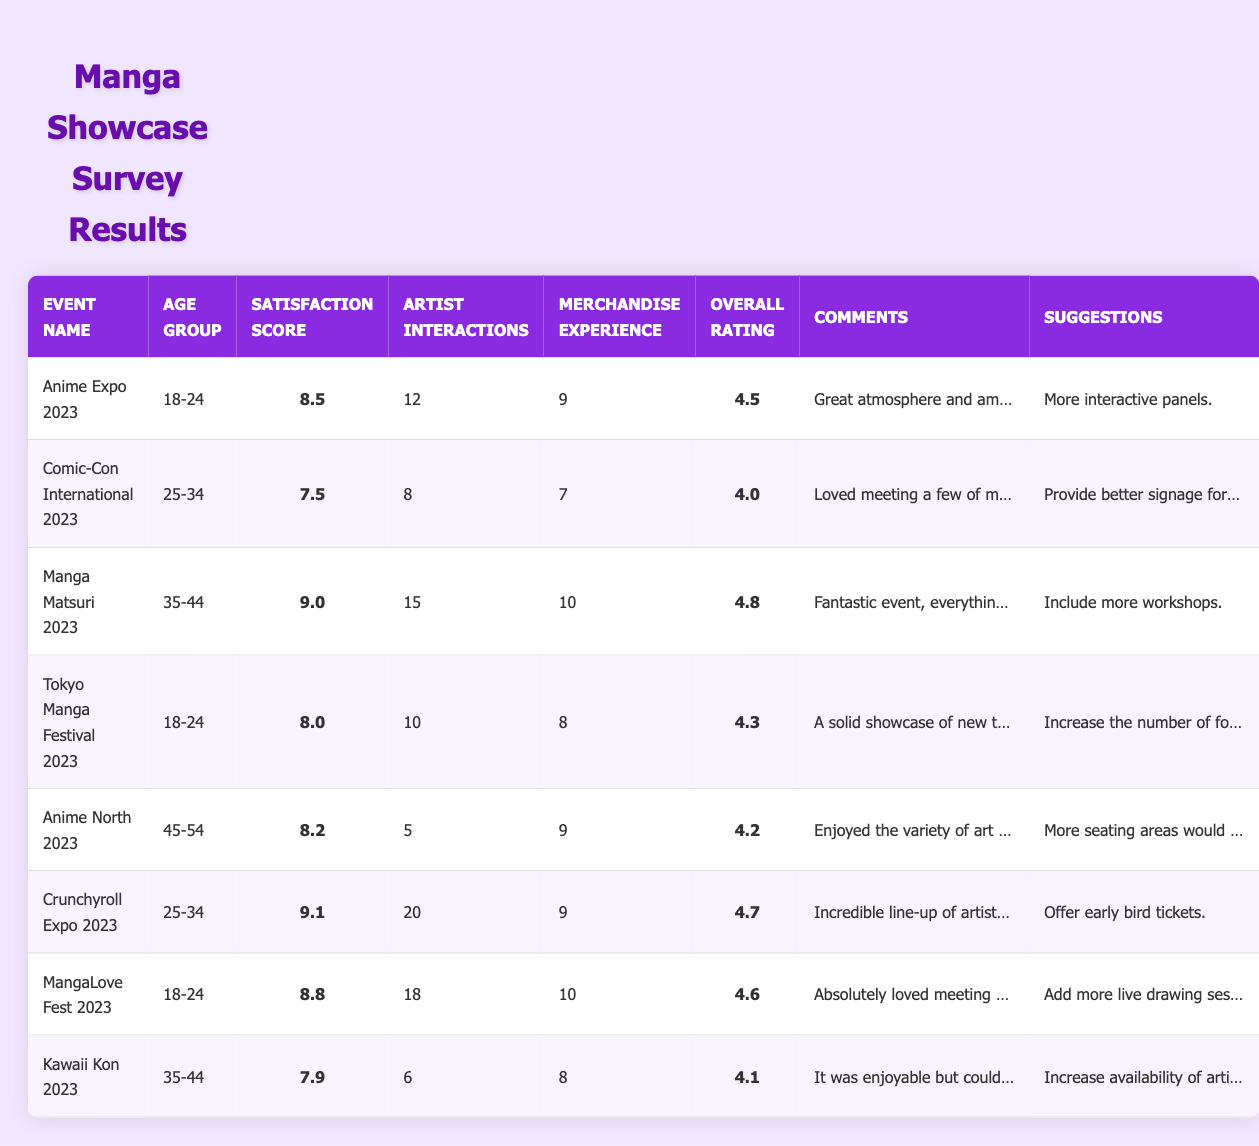What is the satisfaction score for Manga Matsuri 2023? Looking at the table, the satisfaction score for Manga Matsuri 2023 is listed as 9.0.
Answer: 9.0 Which event received the highest overall rating? The overall ratings are compared across the table, and Manga Matsuri 2023 has the highest overall rating at 4.8.
Answer: Manga Matsuri 2023 How many artist interactions were reported at Crunchyroll Expo 2023? The number of artist interactions for Crunchyroll Expo 2023 is explicitly listed in the table, and it is 20.
Answer: 20 What is the average satisfaction score among events for the 18-24 age group? The satisfaction scores for the 18-24 age group from the table are 8.5 (Anime Expo), 8.0 (Tokyo Manga Festival), and 8.8 (MangaLove Fest). To find the average, we sum these scores (8.5 + 8.0 + 8.8 = 25.3) and divide by the number of events (3), resulting in an average of 25.3 / 3 = 8.4333, which is approximately 8.43.
Answer: 8.43 True or False: The merchandise experience for Kawaii Kon 2023 is higher than that for Comic-Con International 2023. The merchandise experience for Kawaii Kon 2023 is 8, while for Comic-Con International 2023 it is 7. Therefore, since 8 is greater than 7, the statement is true.
Answer: True What suggestion was made most frequently across the showcased events? Analyzing the suggestions provided, "More interactive panels" and "Include more workshops" seem common. However, "More interactive panels" appears only once while suggestions such as "Add more live drawing sessions" also appear once. Thus, there isn't a specific suggestion noted more than once among different events.
Answer: No frequently recurring suggestion What is the difference in satisfaction scores between the highest and lowest-rated events? The highest satisfaction score from the table is 9.1 (Crunchyroll Expo 2023) and the lowest is 7.5 (Comic-Con International 2023). To find the difference, we subtract the lowest from the highest (9.1 - 7.5 = 1.6).
Answer: 1.6 Which age group had the lowest number of artist interactions on average? The age group data points for artist interactions are as follows: 18-24 (average: 13.3 - from Anime Expo, Tokyo Manga Festival, and MangaLove Fest), 25-34 (average: 14 - from Comic-Con International and Crunchyroll Expo), and 35-44 (average: 8.0 - from Manga Matsuri and Kawaii Kon). Here, the age group 35-44 has the lowest average artist interactions (6), hence, it has the fewest interactions in total.
Answer: 35-44 What were the comments for the event with the highest satisfaction score? The event with the highest satisfaction score is Crunchyroll Expo 2023, which had comments stating "Incredible line-up of artists and sessions!" as per the table.
Answer: Incredible line-up of artists and sessions! 